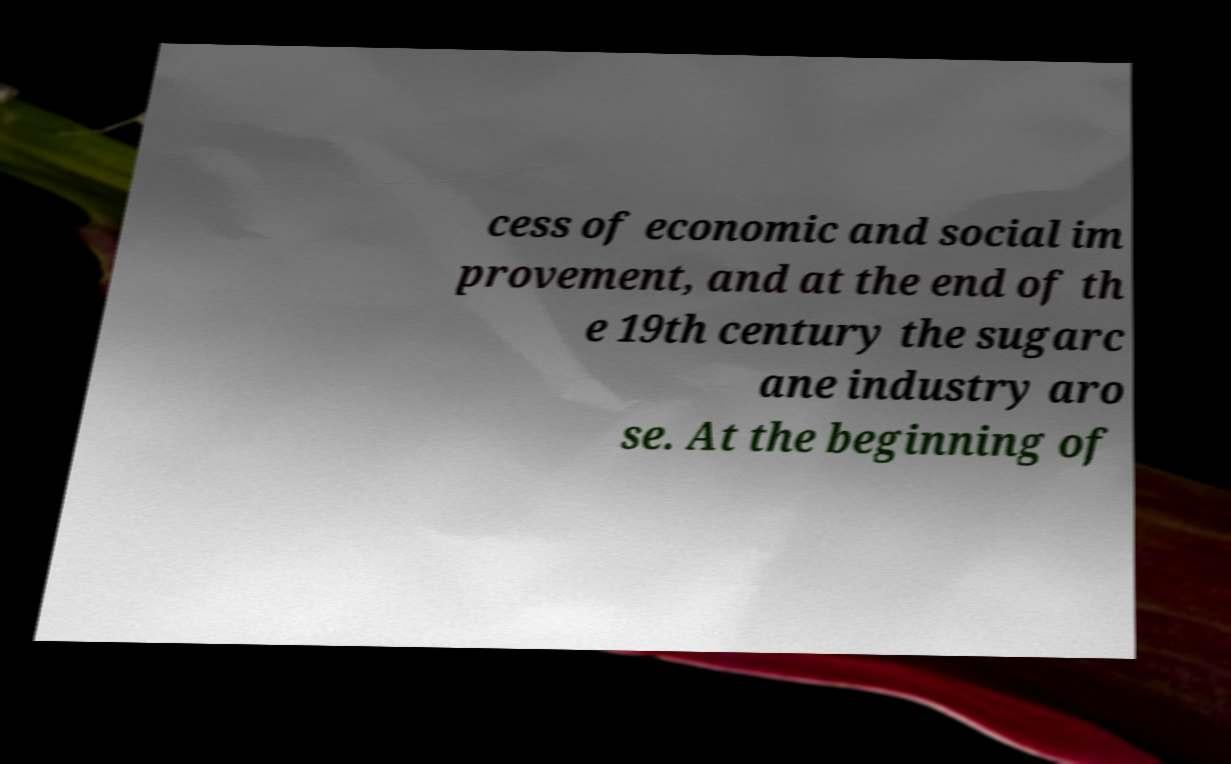Could you assist in decoding the text presented in this image and type it out clearly? cess of economic and social im provement, and at the end of th e 19th century the sugarc ane industry aro se. At the beginning of 